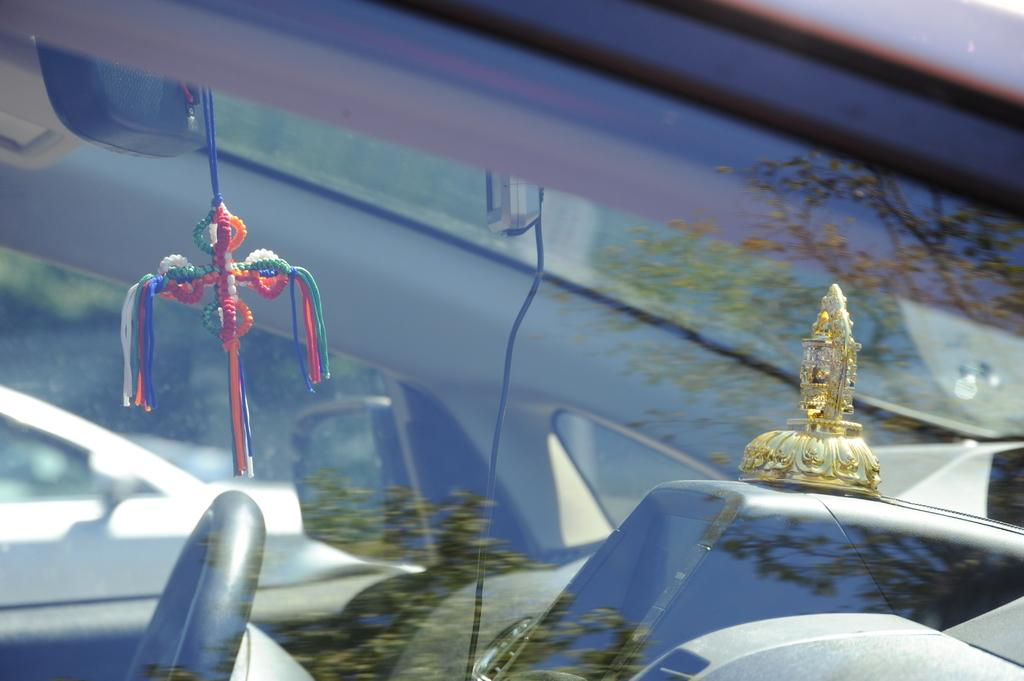Where was the image taken? The image is taken outdoors. What can be seen in the image besides the outdoor setting? There is a car in the image. Can we see the interior of the car? Yes, we can see inside the car through the window. Is there a cook preparing food inside the car in the image? No, there is no cook or food preparation visible in the image. The image only shows a car with a visible interior through the window. 